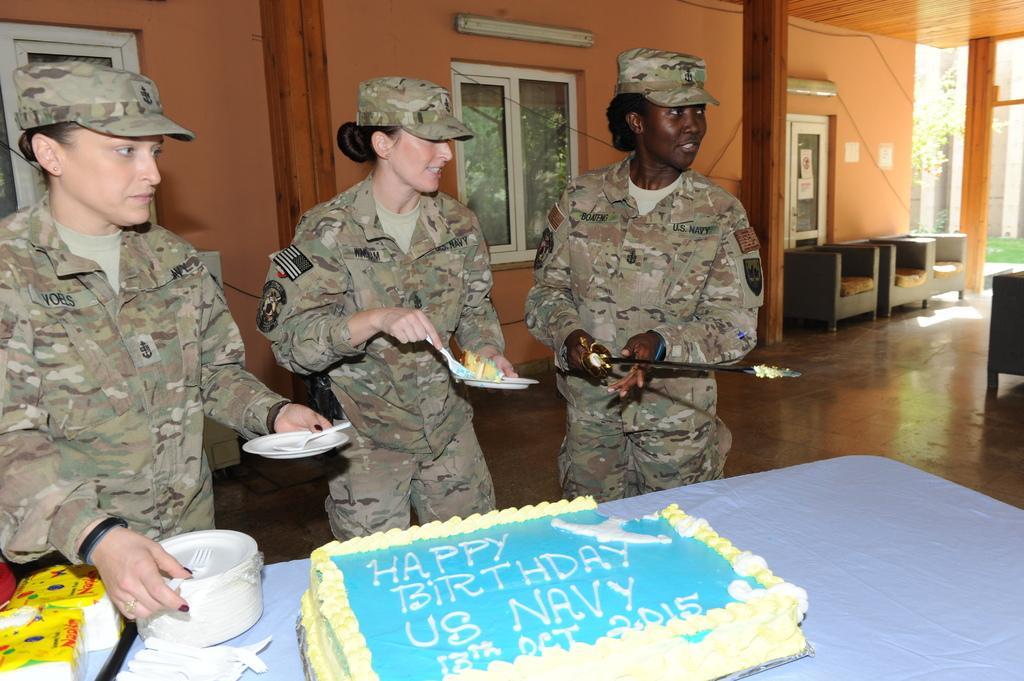Describe this image in one or two sentences. In this image we can see three people wearing a uniform and holding some objects and there is a table in front of them and on the table, we can see the cake, plates, spoons and some other objects. In the background, we can see the building with windows and there are some chairs. 